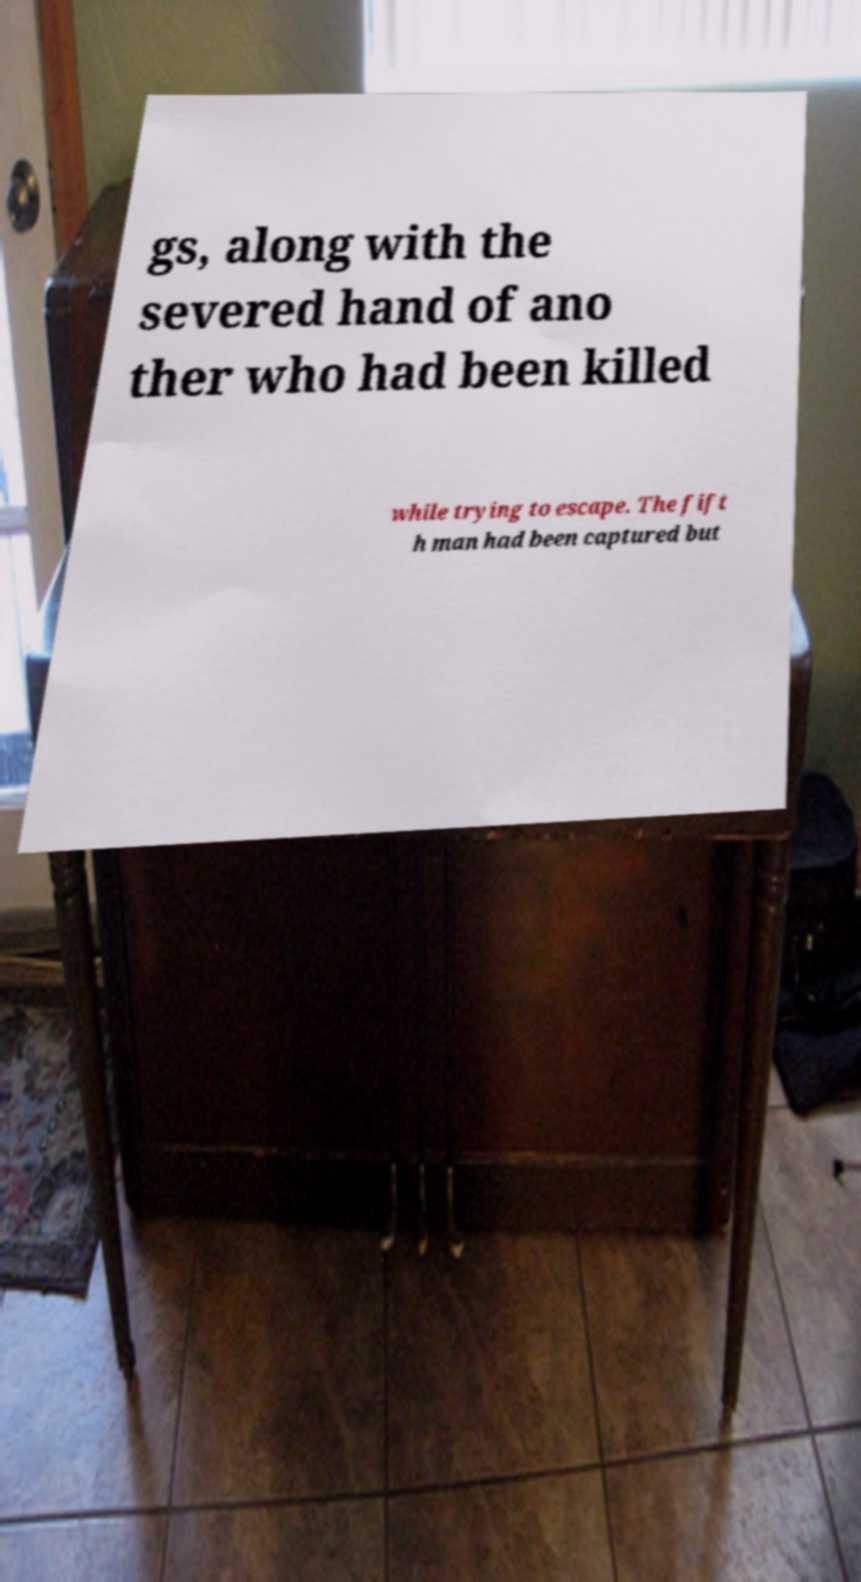Please identify and transcribe the text found in this image. gs, along with the severed hand of ano ther who had been killed while trying to escape. The fift h man had been captured but 